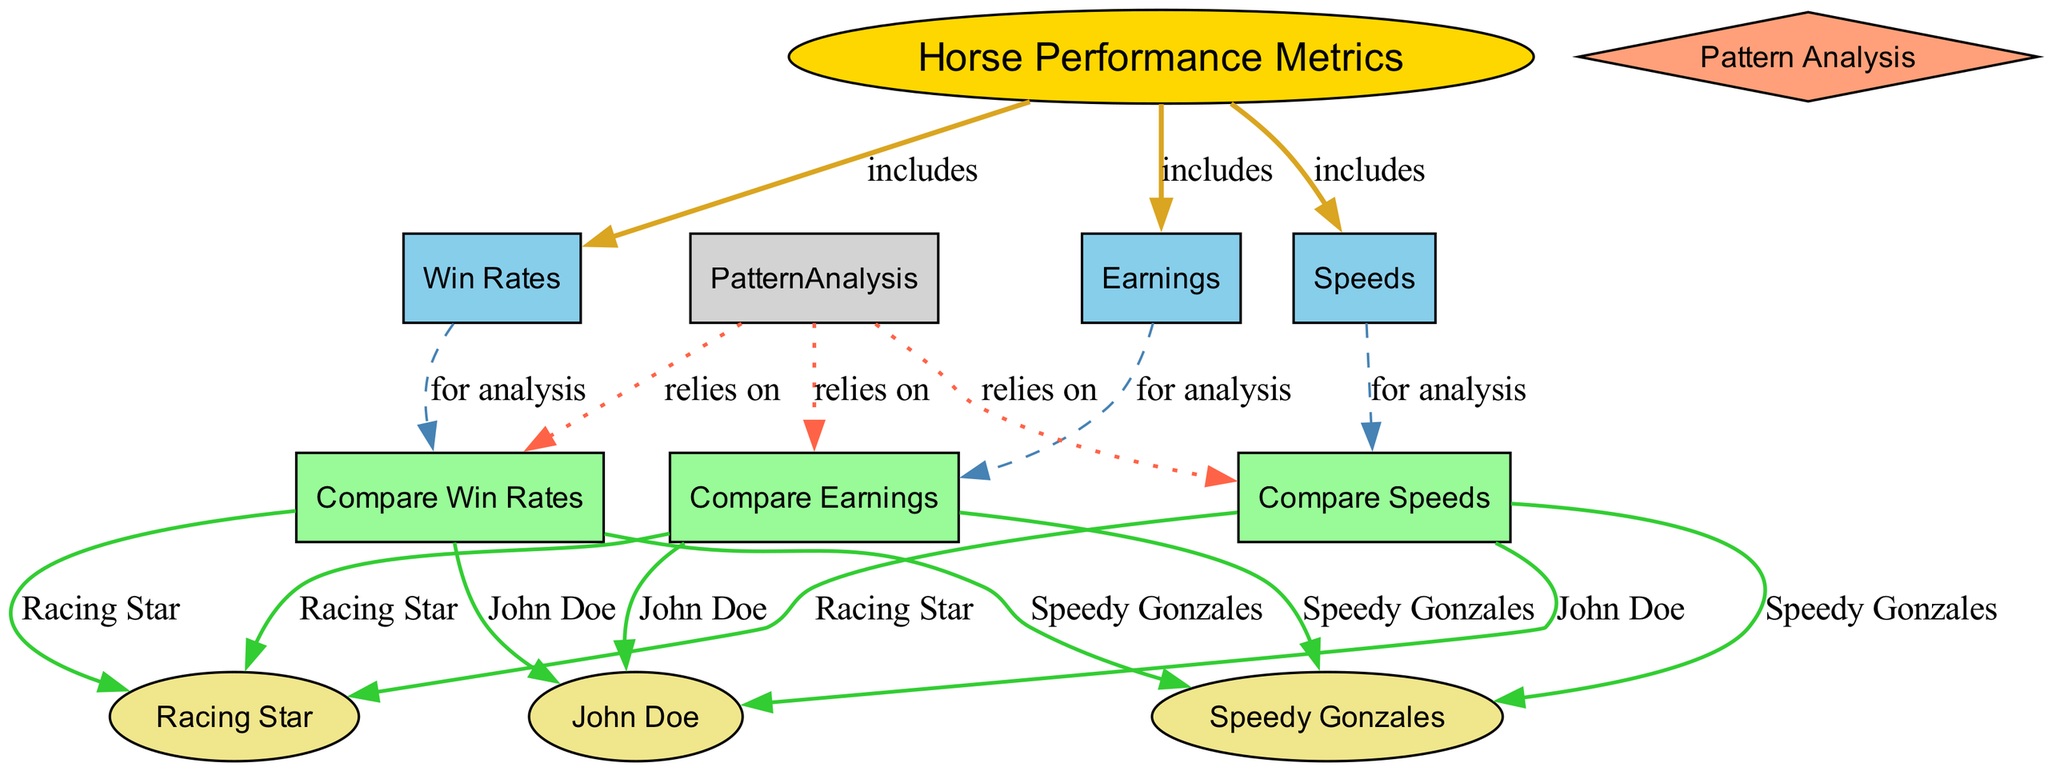What are the three main horse performance metrics included in the diagram? The diagram lists three main performance metrics under the "Horse Performance Metrics" node, which are Win Rates, Speeds, and Earnings.
Answer: Win Rates, Speeds, Earnings How many nodes are there in the diagram? By counting all the unique entries in the "nodes" list from the data, the total number is found to be eleven.
Answer: 11 What types of analysis rely on comparing Win Rates? The "Pattern Analysis" node is connected to the "Compare Win Rates" node, indicating that it relies on that comparison for analysis.
Answer: Pattern Analysis Which horse is associated with comparing speeds? The "Compare Speeds" node connects to "John Doe," "Racing Star," and "Speedy Gonzales," indicating that all these horses are associated with speed comparisons.
Answer: John Doe, Racing Star, Speedy Gonzales How does Pattern Analysis relate to the other metrics? The "Pattern Analysis" node is shown to rely on "Compare Win Rates," "Compare Speeds," and "Compare Earnings," suggesting that it synthesizes insights from all these comparative analyses.
Answer: It relies on all three Which horse has all three comparisons indicated in the diagram? By examining the connections from the comparison nodes, "John Doe," "Racing Star," and "Speedy Gonzales" all appear across the three comparative analysis nodes, confirming their inclusion in the comparisons for each metric.
Answer: John Doe, Racing Star, Speedy Gonzales What does each comparative analysis node utilize for its evaluations? Each comparative analysis node—"Compare Win Rates," "Compare Speeds," and "Compare Earnings"—utilizes the respective main metrics for analysis, as indicated by their connection to the Win Rates, Speeds, and Earnings nodes.
Answer: Each comparative node utilizes its respective metric for analysis How many connections are there from the Horse Performance Metrics node? The "Horse Performance Metrics" node connects to three nodes: "Win Rates," "Speeds," and "Earnings," resulting in a total of three connections.
Answer: 3 Which node provides a visual representation of performance metrics? The node titled "Horse Performance Metrics" serves as the central hub and visually represents the performance metrics.
Answer: Horse Performance Metrics 